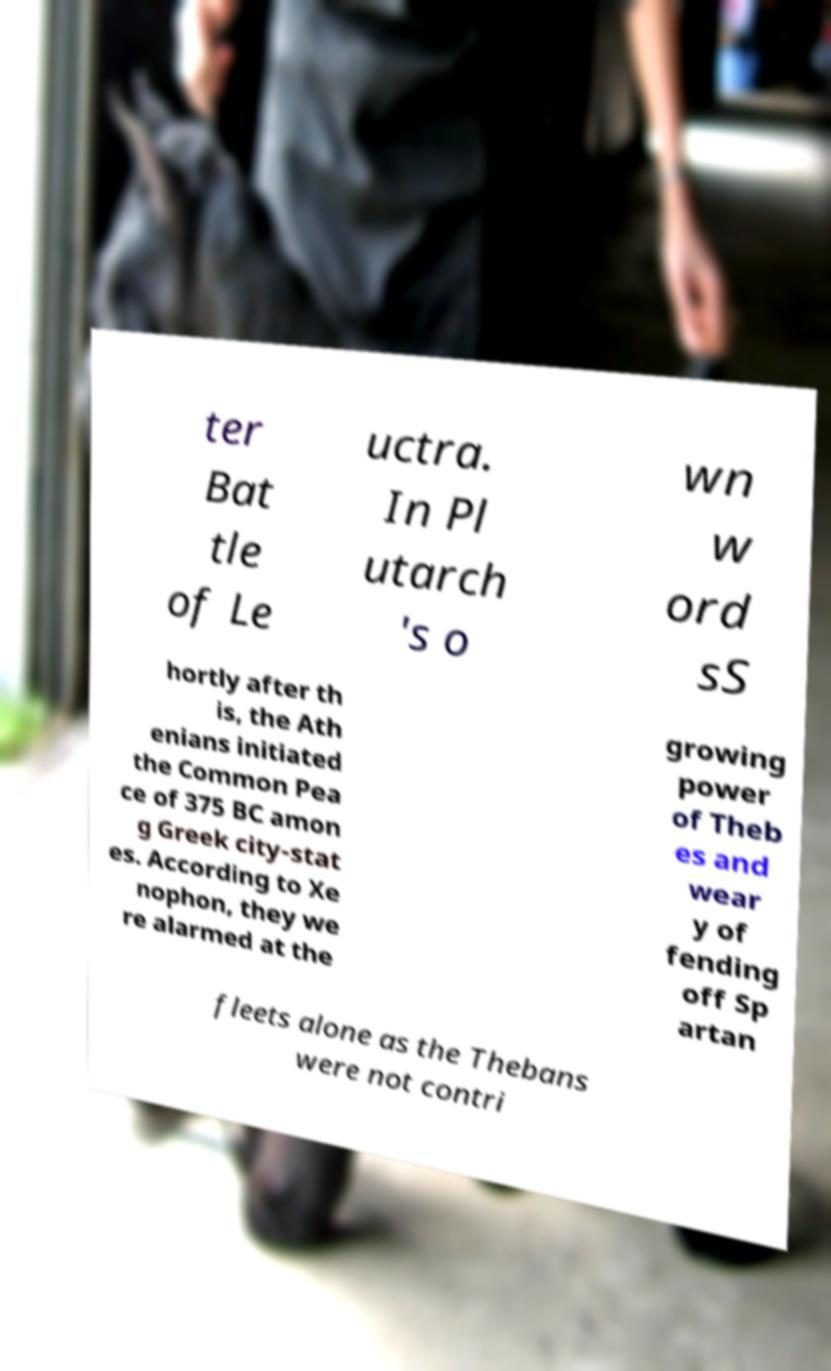Can you accurately transcribe the text from the provided image for me? ter Bat tle of Le uctra. In Pl utarch 's o wn w ord sS hortly after th is, the Ath enians initiated the Common Pea ce of 375 BC amon g Greek city-stat es. According to Xe nophon, they we re alarmed at the growing power of Theb es and wear y of fending off Sp artan fleets alone as the Thebans were not contri 